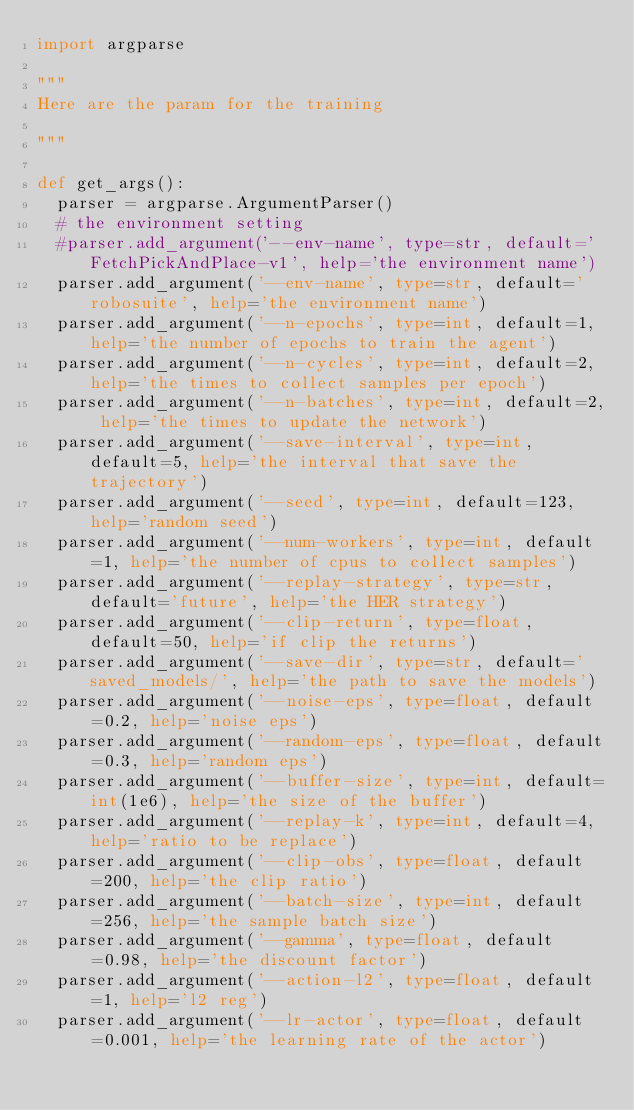Convert code to text. <code><loc_0><loc_0><loc_500><loc_500><_Python_>import argparse

"""
Here are the param for the training

"""

def get_args():
	parser = argparse.ArgumentParser()
	# the environment setting
	#parser.add_argument('--env-name', type=str, default='FetchPickAndPlace-v1', help='the environment name')
	parser.add_argument('--env-name', type=str, default='robosuite', help='the environment name')
	parser.add_argument('--n-epochs', type=int, default=1, help='the number of epochs to train the agent')
	parser.add_argument('--n-cycles', type=int, default=2, help='the times to collect samples per epoch')
	parser.add_argument('--n-batches', type=int, default=2, help='the times to update the network')
	parser.add_argument('--save-interval', type=int, default=5, help='the interval that save the trajectory')
	parser.add_argument('--seed', type=int, default=123, help='random seed')
	parser.add_argument('--num-workers', type=int, default=1, help='the number of cpus to collect samples')
	parser.add_argument('--replay-strategy', type=str, default='future', help='the HER strategy')
	parser.add_argument('--clip-return', type=float, default=50, help='if clip the returns')
	parser.add_argument('--save-dir', type=str, default='saved_models/', help='the path to save the models')
	parser.add_argument('--noise-eps', type=float, default=0.2, help='noise eps')
	parser.add_argument('--random-eps', type=float, default=0.3, help='random eps')
	parser.add_argument('--buffer-size', type=int, default=int(1e6), help='the size of the buffer')
	parser.add_argument('--replay-k', type=int, default=4, help='ratio to be replace')
	parser.add_argument('--clip-obs', type=float, default=200, help='the clip ratio')
	parser.add_argument('--batch-size', type=int, default=256, help='the sample batch size')
	parser.add_argument('--gamma', type=float, default=0.98, help='the discount factor')
	parser.add_argument('--action-l2', type=float, default=1, help='l2 reg')
	parser.add_argument('--lr-actor', type=float, default=0.001, help='the learning rate of the actor')</code> 